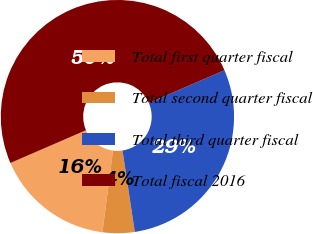Convert chart. <chart><loc_0><loc_0><loc_500><loc_500><pie_chart><fcel>Total first quarter fiscal<fcel>Total second quarter fiscal<fcel>Total third quarter fiscal<fcel>Total fiscal 2016<nl><fcel>16.44%<fcel>4.43%<fcel>29.13%<fcel>50.0%<nl></chart> 